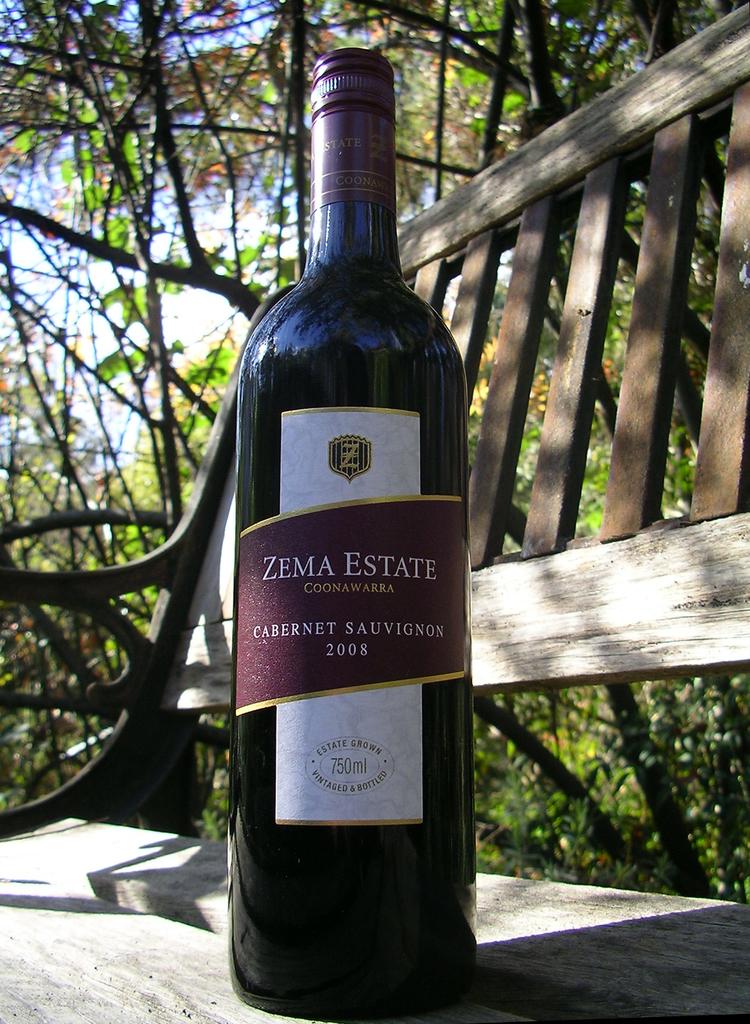What is the year on the wine?
Your response must be concise. 2008. 